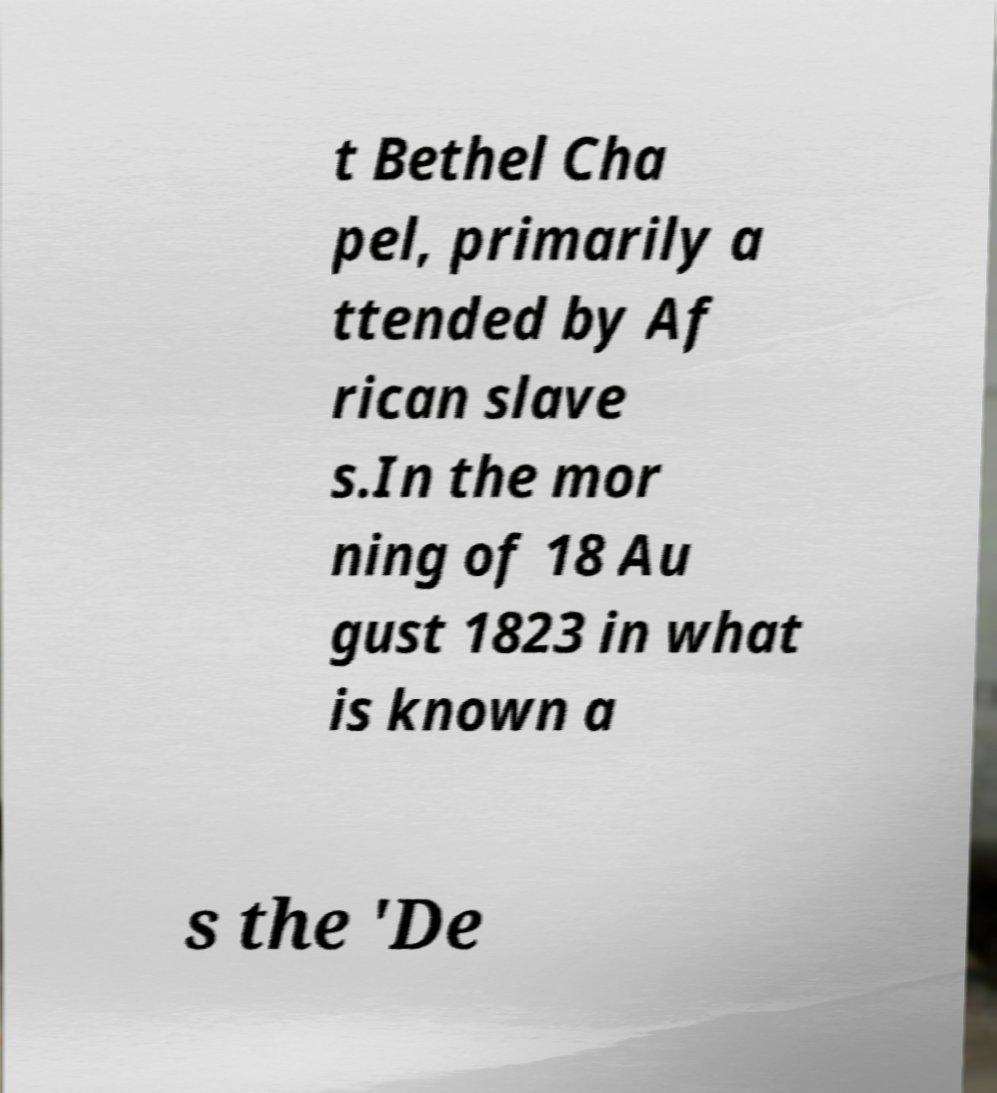I need the written content from this picture converted into text. Can you do that? t Bethel Cha pel, primarily a ttended by Af rican slave s.In the mor ning of 18 Au gust 1823 in what is known a s the 'De 